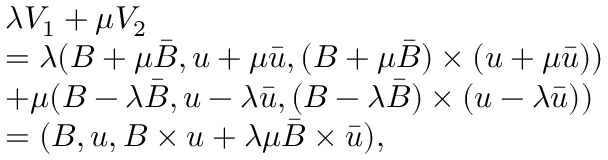<formula> <loc_0><loc_0><loc_500><loc_500>\begin{array} { r l } & { \lambda V _ { 1 } + \mu V _ { 2 } } \\ & { = \lambda ( B + \mu \bar { B } , u + \mu \bar { u } , ( B + \mu \bar { B } ) \times ( u + \mu \bar { u } ) ) } \\ & { + \mu ( B - \lambda \bar { B } , u - \lambda \bar { u } , ( B - \lambda \bar { B } ) \times ( u - \lambda \bar { u } ) ) } \\ & { = ( B , u , B \times u + \lambda \mu \bar { B } \times \bar { u } ) , } \end{array}</formula> 